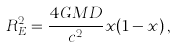<formula> <loc_0><loc_0><loc_500><loc_500>R _ { E } ^ { 2 } = \frac { 4 G M D } { c ^ { 2 } } x ( 1 - x ) \, ,</formula> 